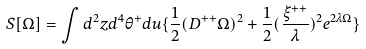Convert formula to latex. <formula><loc_0><loc_0><loc_500><loc_500>S [ \Omega ] = \int d ^ { 2 } z d ^ { 4 } \theta ^ { + } d u \{ \frac { 1 } { 2 } ( D ^ { + + } \Omega ) ^ { 2 } + \frac { 1 } { 2 } ( \frac { \xi ^ { + + } } { \lambda } ) ^ { 2 } e ^ { 2 \lambda \Omega } \}</formula> 